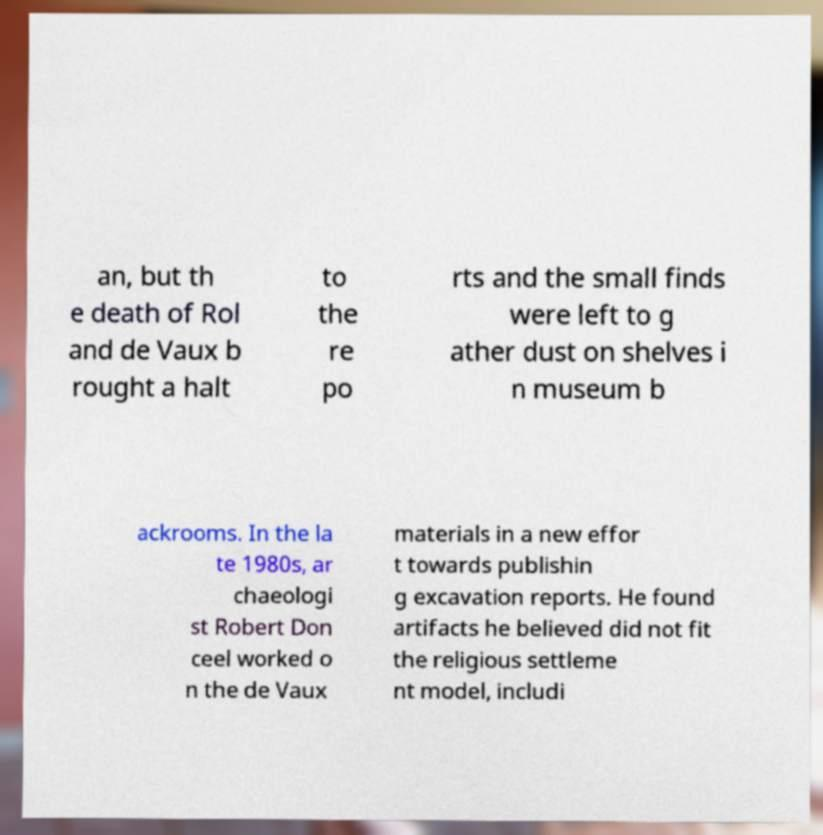Please identify and transcribe the text found in this image. an, but th e death of Rol and de Vaux b rought a halt to the re po rts and the small finds were left to g ather dust on shelves i n museum b ackrooms. In the la te 1980s, ar chaeologi st Robert Don ceel worked o n the de Vaux materials in a new effor t towards publishin g excavation reports. He found artifacts he believed did not fit the religious settleme nt model, includi 